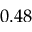Convert formula to latex. <formula><loc_0><loc_0><loc_500><loc_500>0 . 4 8</formula> 